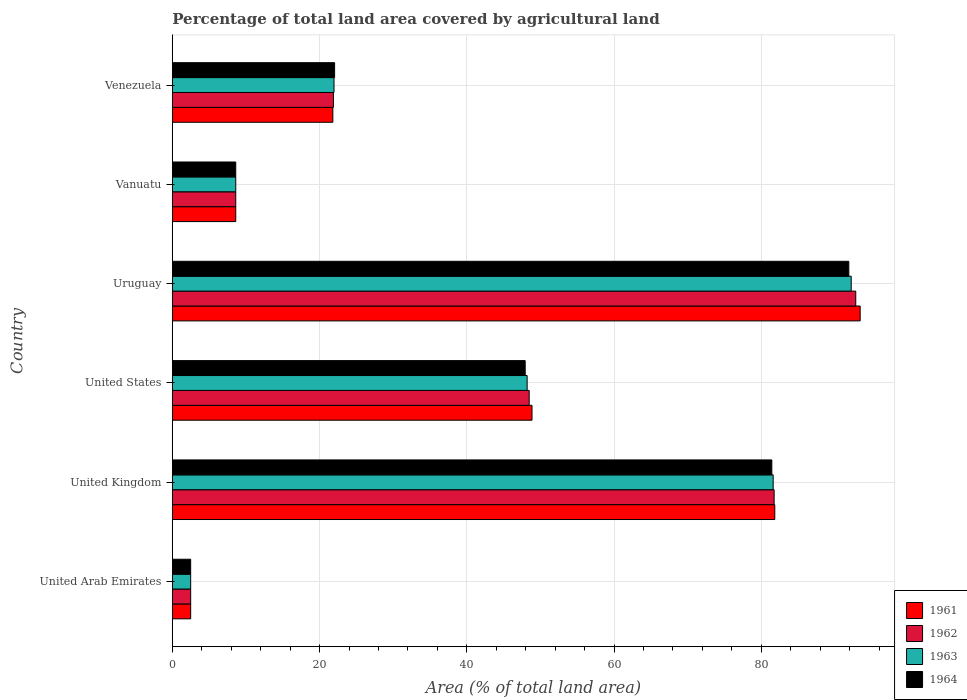How many different coloured bars are there?
Offer a very short reply. 4. How many groups of bars are there?
Keep it short and to the point. 6. How many bars are there on the 1st tick from the top?
Offer a very short reply. 4. How many bars are there on the 3rd tick from the bottom?
Your answer should be very brief. 4. What is the label of the 1st group of bars from the top?
Your response must be concise. Venezuela. What is the percentage of agricultural land in 1963 in Uruguay?
Offer a very short reply. 92.22. Across all countries, what is the maximum percentage of agricultural land in 1963?
Ensure brevity in your answer.  92.22. Across all countries, what is the minimum percentage of agricultural land in 1961?
Provide a short and direct response. 2.49. In which country was the percentage of agricultural land in 1962 maximum?
Offer a very short reply. Uruguay. In which country was the percentage of agricultural land in 1961 minimum?
Provide a succinct answer. United Arab Emirates. What is the total percentage of agricultural land in 1964 in the graph?
Ensure brevity in your answer.  254.42. What is the difference between the percentage of agricultural land in 1962 in Vanuatu and that in Venezuela?
Offer a terse response. -13.27. What is the difference between the percentage of agricultural land in 1961 in Uruguay and the percentage of agricultural land in 1962 in United Arab Emirates?
Your answer should be compact. 90.95. What is the average percentage of agricultural land in 1964 per country?
Offer a very short reply. 42.4. What is the difference between the percentage of agricultural land in 1962 and percentage of agricultural land in 1963 in Venezuela?
Keep it short and to the point. -0.08. What is the ratio of the percentage of agricultural land in 1962 in United Arab Emirates to that in United Kingdom?
Ensure brevity in your answer.  0.03. Is the difference between the percentage of agricultural land in 1962 in United States and Vanuatu greater than the difference between the percentage of agricultural land in 1963 in United States and Vanuatu?
Your answer should be compact. Yes. What is the difference between the highest and the second highest percentage of agricultural land in 1964?
Offer a very short reply. 10.46. What is the difference between the highest and the lowest percentage of agricultural land in 1961?
Provide a short and direct response. 90.95. What does the 4th bar from the bottom in Vanuatu represents?
Offer a terse response. 1964. Are all the bars in the graph horizontal?
Keep it short and to the point. Yes. How many countries are there in the graph?
Offer a very short reply. 6. Are the values on the major ticks of X-axis written in scientific E-notation?
Offer a terse response. No. Does the graph contain any zero values?
Offer a terse response. No. Where does the legend appear in the graph?
Ensure brevity in your answer.  Bottom right. How many legend labels are there?
Keep it short and to the point. 4. What is the title of the graph?
Provide a succinct answer. Percentage of total land area covered by agricultural land. What is the label or title of the X-axis?
Keep it short and to the point. Area (% of total land area). What is the Area (% of total land area) in 1961 in United Arab Emirates?
Give a very brief answer. 2.49. What is the Area (% of total land area) of 1962 in United Arab Emirates?
Keep it short and to the point. 2.49. What is the Area (% of total land area) in 1963 in United Arab Emirates?
Provide a succinct answer. 2.49. What is the Area (% of total land area) in 1964 in United Arab Emirates?
Give a very brief answer. 2.49. What is the Area (% of total land area) in 1961 in United Kingdom?
Your response must be concise. 81.84. What is the Area (% of total land area) of 1962 in United Kingdom?
Make the answer very short. 81.76. What is the Area (% of total land area) of 1963 in United Kingdom?
Your response must be concise. 81.62. What is the Area (% of total land area) in 1964 in United Kingdom?
Keep it short and to the point. 81.44. What is the Area (% of total land area) in 1961 in United States?
Your answer should be very brief. 48.86. What is the Area (% of total land area) of 1962 in United States?
Provide a short and direct response. 48.48. What is the Area (% of total land area) of 1963 in United States?
Keep it short and to the point. 48.2. What is the Area (% of total land area) in 1964 in United States?
Offer a terse response. 47.93. What is the Area (% of total land area) in 1961 in Uruguay?
Provide a short and direct response. 93.44. What is the Area (% of total land area) of 1962 in Uruguay?
Offer a very short reply. 92.84. What is the Area (% of total land area) of 1963 in Uruguay?
Your answer should be compact. 92.22. What is the Area (% of total land area) of 1964 in Uruguay?
Your answer should be compact. 91.9. What is the Area (% of total land area) in 1961 in Vanuatu?
Ensure brevity in your answer.  8.61. What is the Area (% of total land area) in 1962 in Vanuatu?
Your response must be concise. 8.61. What is the Area (% of total land area) in 1963 in Vanuatu?
Give a very brief answer. 8.61. What is the Area (% of total land area) in 1964 in Vanuatu?
Provide a short and direct response. 8.61. What is the Area (% of total land area) in 1961 in Venezuela?
Your answer should be very brief. 21.8. What is the Area (% of total land area) of 1962 in Venezuela?
Your response must be concise. 21.88. What is the Area (% of total land area) of 1963 in Venezuela?
Offer a terse response. 21.96. What is the Area (% of total land area) in 1964 in Venezuela?
Your response must be concise. 22.04. Across all countries, what is the maximum Area (% of total land area) in 1961?
Offer a terse response. 93.44. Across all countries, what is the maximum Area (% of total land area) in 1962?
Keep it short and to the point. 92.84. Across all countries, what is the maximum Area (% of total land area) of 1963?
Offer a terse response. 92.22. Across all countries, what is the maximum Area (% of total land area) in 1964?
Give a very brief answer. 91.9. Across all countries, what is the minimum Area (% of total land area) of 1961?
Provide a short and direct response. 2.49. Across all countries, what is the minimum Area (% of total land area) in 1962?
Give a very brief answer. 2.49. Across all countries, what is the minimum Area (% of total land area) of 1963?
Your response must be concise. 2.49. Across all countries, what is the minimum Area (% of total land area) in 1964?
Offer a terse response. 2.49. What is the total Area (% of total land area) in 1961 in the graph?
Keep it short and to the point. 257.05. What is the total Area (% of total land area) in 1962 in the graph?
Keep it short and to the point. 256.06. What is the total Area (% of total land area) of 1963 in the graph?
Make the answer very short. 255.11. What is the total Area (% of total land area) in 1964 in the graph?
Give a very brief answer. 254.42. What is the difference between the Area (% of total land area) of 1961 in United Arab Emirates and that in United Kingdom?
Give a very brief answer. -79.35. What is the difference between the Area (% of total land area) in 1962 in United Arab Emirates and that in United Kingdom?
Offer a terse response. -79.27. What is the difference between the Area (% of total land area) of 1963 in United Arab Emirates and that in United Kingdom?
Offer a terse response. -79.13. What is the difference between the Area (% of total land area) in 1964 in United Arab Emirates and that in United Kingdom?
Keep it short and to the point. -78.95. What is the difference between the Area (% of total land area) of 1961 in United Arab Emirates and that in United States?
Keep it short and to the point. -46.37. What is the difference between the Area (% of total land area) in 1962 in United Arab Emirates and that in United States?
Make the answer very short. -45.99. What is the difference between the Area (% of total land area) of 1963 in United Arab Emirates and that in United States?
Offer a very short reply. -45.71. What is the difference between the Area (% of total land area) in 1964 in United Arab Emirates and that in United States?
Offer a very short reply. -45.44. What is the difference between the Area (% of total land area) in 1961 in United Arab Emirates and that in Uruguay?
Ensure brevity in your answer.  -90.95. What is the difference between the Area (% of total land area) of 1962 in United Arab Emirates and that in Uruguay?
Your answer should be compact. -90.35. What is the difference between the Area (% of total land area) in 1963 in United Arab Emirates and that in Uruguay?
Provide a short and direct response. -89.74. What is the difference between the Area (% of total land area) of 1964 in United Arab Emirates and that in Uruguay?
Offer a terse response. -89.41. What is the difference between the Area (% of total land area) in 1961 in United Arab Emirates and that in Vanuatu?
Provide a succinct answer. -6.13. What is the difference between the Area (% of total land area) in 1962 in United Arab Emirates and that in Vanuatu?
Offer a terse response. -6.13. What is the difference between the Area (% of total land area) of 1963 in United Arab Emirates and that in Vanuatu?
Your answer should be very brief. -6.13. What is the difference between the Area (% of total land area) in 1964 in United Arab Emirates and that in Vanuatu?
Provide a succinct answer. -6.13. What is the difference between the Area (% of total land area) in 1961 in United Arab Emirates and that in Venezuela?
Your answer should be compact. -19.32. What is the difference between the Area (% of total land area) of 1962 in United Arab Emirates and that in Venezuela?
Provide a succinct answer. -19.4. What is the difference between the Area (% of total land area) in 1963 in United Arab Emirates and that in Venezuela?
Provide a short and direct response. -19.47. What is the difference between the Area (% of total land area) of 1964 in United Arab Emirates and that in Venezuela?
Your response must be concise. -19.56. What is the difference between the Area (% of total land area) in 1961 in United Kingdom and that in United States?
Your answer should be compact. 32.98. What is the difference between the Area (% of total land area) in 1962 in United Kingdom and that in United States?
Offer a very short reply. 33.28. What is the difference between the Area (% of total land area) in 1963 in United Kingdom and that in United States?
Provide a succinct answer. 33.42. What is the difference between the Area (% of total land area) of 1964 in United Kingdom and that in United States?
Provide a short and direct response. 33.51. What is the difference between the Area (% of total land area) in 1961 in United Kingdom and that in Uruguay?
Provide a succinct answer. -11.6. What is the difference between the Area (% of total land area) in 1962 in United Kingdom and that in Uruguay?
Provide a short and direct response. -11.09. What is the difference between the Area (% of total land area) in 1963 in United Kingdom and that in Uruguay?
Your answer should be very brief. -10.6. What is the difference between the Area (% of total land area) of 1964 in United Kingdom and that in Uruguay?
Your response must be concise. -10.46. What is the difference between the Area (% of total land area) in 1961 in United Kingdom and that in Vanuatu?
Ensure brevity in your answer.  73.23. What is the difference between the Area (% of total land area) in 1962 in United Kingdom and that in Vanuatu?
Provide a succinct answer. 73.14. What is the difference between the Area (% of total land area) in 1963 in United Kingdom and that in Vanuatu?
Provide a short and direct response. 73.01. What is the difference between the Area (% of total land area) of 1964 in United Kingdom and that in Vanuatu?
Your answer should be compact. 72.83. What is the difference between the Area (% of total land area) of 1961 in United Kingdom and that in Venezuela?
Your answer should be compact. 60.04. What is the difference between the Area (% of total land area) of 1962 in United Kingdom and that in Venezuela?
Offer a very short reply. 59.87. What is the difference between the Area (% of total land area) in 1963 in United Kingdom and that in Venezuela?
Offer a terse response. 59.66. What is the difference between the Area (% of total land area) in 1964 in United Kingdom and that in Venezuela?
Offer a terse response. 59.4. What is the difference between the Area (% of total land area) of 1961 in United States and that in Uruguay?
Your answer should be compact. -44.58. What is the difference between the Area (% of total land area) in 1962 in United States and that in Uruguay?
Offer a very short reply. -44.36. What is the difference between the Area (% of total land area) of 1963 in United States and that in Uruguay?
Offer a terse response. -44.03. What is the difference between the Area (% of total land area) in 1964 in United States and that in Uruguay?
Your response must be concise. -43.97. What is the difference between the Area (% of total land area) of 1961 in United States and that in Vanuatu?
Keep it short and to the point. 40.25. What is the difference between the Area (% of total land area) of 1962 in United States and that in Vanuatu?
Your response must be concise. 39.86. What is the difference between the Area (% of total land area) of 1963 in United States and that in Vanuatu?
Your answer should be very brief. 39.58. What is the difference between the Area (% of total land area) in 1964 in United States and that in Vanuatu?
Keep it short and to the point. 39.32. What is the difference between the Area (% of total land area) of 1961 in United States and that in Venezuela?
Make the answer very short. 27.06. What is the difference between the Area (% of total land area) of 1962 in United States and that in Venezuela?
Provide a succinct answer. 26.59. What is the difference between the Area (% of total land area) in 1963 in United States and that in Venezuela?
Ensure brevity in your answer.  26.24. What is the difference between the Area (% of total land area) of 1964 in United States and that in Venezuela?
Your response must be concise. 25.89. What is the difference between the Area (% of total land area) in 1961 in Uruguay and that in Vanuatu?
Provide a succinct answer. 84.83. What is the difference between the Area (% of total land area) in 1962 in Uruguay and that in Vanuatu?
Your answer should be compact. 84.23. What is the difference between the Area (% of total land area) of 1963 in Uruguay and that in Vanuatu?
Your answer should be compact. 83.61. What is the difference between the Area (% of total land area) in 1964 in Uruguay and that in Vanuatu?
Offer a very short reply. 83.28. What is the difference between the Area (% of total land area) in 1961 in Uruguay and that in Venezuela?
Provide a succinct answer. 71.64. What is the difference between the Area (% of total land area) of 1962 in Uruguay and that in Venezuela?
Provide a short and direct response. 70.96. What is the difference between the Area (% of total land area) of 1963 in Uruguay and that in Venezuela?
Ensure brevity in your answer.  70.26. What is the difference between the Area (% of total land area) of 1964 in Uruguay and that in Venezuela?
Provide a short and direct response. 69.85. What is the difference between the Area (% of total land area) in 1961 in Vanuatu and that in Venezuela?
Keep it short and to the point. -13.19. What is the difference between the Area (% of total land area) in 1962 in Vanuatu and that in Venezuela?
Provide a succinct answer. -13.27. What is the difference between the Area (% of total land area) in 1963 in Vanuatu and that in Venezuela?
Provide a short and direct response. -13.35. What is the difference between the Area (% of total land area) in 1964 in Vanuatu and that in Venezuela?
Ensure brevity in your answer.  -13.43. What is the difference between the Area (% of total land area) of 1961 in United Arab Emirates and the Area (% of total land area) of 1962 in United Kingdom?
Ensure brevity in your answer.  -79.27. What is the difference between the Area (% of total land area) of 1961 in United Arab Emirates and the Area (% of total land area) of 1963 in United Kingdom?
Keep it short and to the point. -79.13. What is the difference between the Area (% of total land area) of 1961 in United Arab Emirates and the Area (% of total land area) of 1964 in United Kingdom?
Make the answer very short. -78.95. What is the difference between the Area (% of total land area) in 1962 in United Arab Emirates and the Area (% of total land area) in 1963 in United Kingdom?
Provide a succinct answer. -79.13. What is the difference between the Area (% of total land area) in 1962 in United Arab Emirates and the Area (% of total land area) in 1964 in United Kingdom?
Make the answer very short. -78.95. What is the difference between the Area (% of total land area) of 1963 in United Arab Emirates and the Area (% of total land area) of 1964 in United Kingdom?
Provide a succinct answer. -78.95. What is the difference between the Area (% of total land area) in 1961 in United Arab Emirates and the Area (% of total land area) in 1962 in United States?
Offer a terse response. -45.99. What is the difference between the Area (% of total land area) in 1961 in United Arab Emirates and the Area (% of total land area) in 1963 in United States?
Your response must be concise. -45.71. What is the difference between the Area (% of total land area) of 1961 in United Arab Emirates and the Area (% of total land area) of 1964 in United States?
Keep it short and to the point. -45.44. What is the difference between the Area (% of total land area) in 1962 in United Arab Emirates and the Area (% of total land area) in 1963 in United States?
Give a very brief answer. -45.71. What is the difference between the Area (% of total land area) of 1962 in United Arab Emirates and the Area (% of total land area) of 1964 in United States?
Give a very brief answer. -45.44. What is the difference between the Area (% of total land area) in 1963 in United Arab Emirates and the Area (% of total land area) in 1964 in United States?
Your response must be concise. -45.44. What is the difference between the Area (% of total land area) of 1961 in United Arab Emirates and the Area (% of total land area) of 1962 in Uruguay?
Your answer should be compact. -90.35. What is the difference between the Area (% of total land area) of 1961 in United Arab Emirates and the Area (% of total land area) of 1963 in Uruguay?
Your answer should be compact. -89.74. What is the difference between the Area (% of total land area) of 1961 in United Arab Emirates and the Area (% of total land area) of 1964 in Uruguay?
Provide a short and direct response. -89.41. What is the difference between the Area (% of total land area) in 1962 in United Arab Emirates and the Area (% of total land area) in 1963 in Uruguay?
Keep it short and to the point. -89.74. What is the difference between the Area (% of total land area) in 1962 in United Arab Emirates and the Area (% of total land area) in 1964 in Uruguay?
Your response must be concise. -89.41. What is the difference between the Area (% of total land area) of 1963 in United Arab Emirates and the Area (% of total land area) of 1964 in Uruguay?
Offer a terse response. -89.41. What is the difference between the Area (% of total land area) of 1961 in United Arab Emirates and the Area (% of total land area) of 1962 in Vanuatu?
Give a very brief answer. -6.13. What is the difference between the Area (% of total land area) in 1961 in United Arab Emirates and the Area (% of total land area) in 1963 in Vanuatu?
Your response must be concise. -6.13. What is the difference between the Area (% of total land area) in 1961 in United Arab Emirates and the Area (% of total land area) in 1964 in Vanuatu?
Provide a short and direct response. -6.13. What is the difference between the Area (% of total land area) in 1962 in United Arab Emirates and the Area (% of total land area) in 1963 in Vanuatu?
Provide a succinct answer. -6.13. What is the difference between the Area (% of total land area) in 1962 in United Arab Emirates and the Area (% of total land area) in 1964 in Vanuatu?
Your answer should be very brief. -6.13. What is the difference between the Area (% of total land area) of 1963 in United Arab Emirates and the Area (% of total land area) of 1964 in Vanuatu?
Your response must be concise. -6.13. What is the difference between the Area (% of total land area) of 1961 in United Arab Emirates and the Area (% of total land area) of 1962 in Venezuela?
Your answer should be very brief. -19.4. What is the difference between the Area (% of total land area) in 1961 in United Arab Emirates and the Area (% of total land area) in 1963 in Venezuela?
Make the answer very short. -19.47. What is the difference between the Area (% of total land area) in 1961 in United Arab Emirates and the Area (% of total land area) in 1964 in Venezuela?
Give a very brief answer. -19.56. What is the difference between the Area (% of total land area) of 1962 in United Arab Emirates and the Area (% of total land area) of 1963 in Venezuela?
Ensure brevity in your answer.  -19.47. What is the difference between the Area (% of total land area) of 1962 in United Arab Emirates and the Area (% of total land area) of 1964 in Venezuela?
Your answer should be compact. -19.56. What is the difference between the Area (% of total land area) in 1963 in United Arab Emirates and the Area (% of total land area) in 1964 in Venezuela?
Ensure brevity in your answer.  -19.56. What is the difference between the Area (% of total land area) in 1961 in United Kingdom and the Area (% of total land area) in 1962 in United States?
Ensure brevity in your answer.  33.37. What is the difference between the Area (% of total land area) of 1961 in United Kingdom and the Area (% of total land area) of 1963 in United States?
Keep it short and to the point. 33.64. What is the difference between the Area (% of total land area) in 1961 in United Kingdom and the Area (% of total land area) in 1964 in United States?
Your answer should be very brief. 33.91. What is the difference between the Area (% of total land area) of 1962 in United Kingdom and the Area (% of total land area) of 1963 in United States?
Keep it short and to the point. 33.56. What is the difference between the Area (% of total land area) in 1962 in United Kingdom and the Area (% of total land area) in 1964 in United States?
Provide a succinct answer. 33.82. What is the difference between the Area (% of total land area) of 1963 in United Kingdom and the Area (% of total land area) of 1964 in United States?
Provide a short and direct response. 33.69. What is the difference between the Area (% of total land area) of 1961 in United Kingdom and the Area (% of total land area) of 1962 in Uruguay?
Your answer should be very brief. -11. What is the difference between the Area (% of total land area) of 1961 in United Kingdom and the Area (% of total land area) of 1963 in Uruguay?
Give a very brief answer. -10.38. What is the difference between the Area (% of total land area) of 1961 in United Kingdom and the Area (% of total land area) of 1964 in Uruguay?
Offer a terse response. -10.06. What is the difference between the Area (% of total land area) of 1962 in United Kingdom and the Area (% of total land area) of 1963 in Uruguay?
Give a very brief answer. -10.47. What is the difference between the Area (% of total land area) in 1962 in United Kingdom and the Area (% of total land area) in 1964 in Uruguay?
Your answer should be compact. -10.14. What is the difference between the Area (% of total land area) of 1963 in United Kingdom and the Area (% of total land area) of 1964 in Uruguay?
Your response must be concise. -10.28. What is the difference between the Area (% of total land area) in 1961 in United Kingdom and the Area (% of total land area) in 1962 in Vanuatu?
Make the answer very short. 73.23. What is the difference between the Area (% of total land area) of 1961 in United Kingdom and the Area (% of total land area) of 1963 in Vanuatu?
Your answer should be very brief. 73.23. What is the difference between the Area (% of total land area) of 1961 in United Kingdom and the Area (% of total land area) of 1964 in Vanuatu?
Your response must be concise. 73.23. What is the difference between the Area (% of total land area) in 1962 in United Kingdom and the Area (% of total land area) in 1963 in Vanuatu?
Your answer should be very brief. 73.14. What is the difference between the Area (% of total land area) of 1962 in United Kingdom and the Area (% of total land area) of 1964 in Vanuatu?
Provide a short and direct response. 73.14. What is the difference between the Area (% of total land area) of 1963 in United Kingdom and the Area (% of total land area) of 1964 in Vanuatu?
Keep it short and to the point. 73.01. What is the difference between the Area (% of total land area) in 1961 in United Kingdom and the Area (% of total land area) in 1962 in Venezuela?
Offer a very short reply. 59.96. What is the difference between the Area (% of total land area) in 1961 in United Kingdom and the Area (% of total land area) in 1963 in Venezuela?
Offer a terse response. 59.88. What is the difference between the Area (% of total land area) of 1961 in United Kingdom and the Area (% of total land area) of 1964 in Venezuela?
Your answer should be very brief. 59.8. What is the difference between the Area (% of total land area) in 1962 in United Kingdom and the Area (% of total land area) in 1963 in Venezuela?
Ensure brevity in your answer.  59.79. What is the difference between the Area (% of total land area) in 1962 in United Kingdom and the Area (% of total land area) in 1964 in Venezuela?
Provide a short and direct response. 59.71. What is the difference between the Area (% of total land area) of 1963 in United Kingdom and the Area (% of total land area) of 1964 in Venezuela?
Provide a short and direct response. 59.58. What is the difference between the Area (% of total land area) of 1961 in United States and the Area (% of total land area) of 1962 in Uruguay?
Make the answer very short. -43.98. What is the difference between the Area (% of total land area) in 1961 in United States and the Area (% of total land area) in 1963 in Uruguay?
Give a very brief answer. -43.36. What is the difference between the Area (% of total land area) in 1961 in United States and the Area (% of total land area) in 1964 in Uruguay?
Your answer should be very brief. -43.04. What is the difference between the Area (% of total land area) of 1962 in United States and the Area (% of total land area) of 1963 in Uruguay?
Give a very brief answer. -43.75. What is the difference between the Area (% of total land area) of 1962 in United States and the Area (% of total land area) of 1964 in Uruguay?
Offer a terse response. -43.42. What is the difference between the Area (% of total land area) of 1963 in United States and the Area (% of total land area) of 1964 in Uruguay?
Your response must be concise. -43.7. What is the difference between the Area (% of total land area) of 1961 in United States and the Area (% of total land area) of 1962 in Vanuatu?
Ensure brevity in your answer.  40.25. What is the difference between the Area (% of total land area) in 1961 in United States and the Area (% of total land area) in 1963 in Vanuatu?
Provide a succinct answer. 40.25. What is the difference between the Area (% of total land area) of 1961 in United States and the Area (% of total land area) of 1964 in Vanuatu?
Your answer should be compact. 40.25. What is the difference between the Area (% of total land area) in 1962 in United States and the Area (% of total land area) in 1963 in Vanuatu?
Make the answer very short. 39.86. What is the difference between the Area (% of total land area) of 1962 in United States and the Area (% of total land area) of 1964 in Vanuatu?
Give a very brief answer. 39.86. What is the difference between the Area (% of total land area) of 1963 in United States and the Area (% of total land area) of 1964 in Vanuatu?
Your answer should be very brief. 39.58. What is the difference between the Area (% of total land area) in 1961 in United States and the Area (% of total land area) in 1962 in Venezuela?
Your answer should be compact. 26.98. What is the difference between the Area (% of total land area) of 1961 in United States and the Area (% of total land area) of 1963 in Venezuela?
Your answer should be compact. 26.9. What is the difference between the Area (% of total land area) of 1961 in United States and the Area (% of total land area) of 1964 in Venezuela?
Provide a succinct answer. 26.82. What is the difference between the Area (% of total land area) in 1962 in United States and the Area (% of total land area) in 1963 in Venezuela?
Your answer should be very brief. 26.51. What is the difference between the Area (% of total land area) in 1962 in United States and the Area (% of total land area) in 1964 in Venezuela?
Ensure brevity in your answer.  26.43. What is the difference between the Area (% of total land area) of 1963 in United States and the Area (% of total land area) of 1964 in Venezuela?
Provide a succinct answer. 26.15. What is the difference between the Area (% of total land area) of 1961 in Uruguay and the Area (% of total land area) of 1962 in Vanuatu?
Your answer should be very brief. 84.83. What is the difference between the Area (% of total land area) in 1961 in Uruguay and the Area (% of total land area) in 1963 in Vanuatu?
Provide a succinct answer. 84.83. What is the difference between the Area (% of total land area) of 1961 in Uruguay and the Area (% of total land area) of 1964 in Vanuatu?
Make the answer very short. 84.83. What is the difference between the Area (% of total land area) of 1962 in Uruguay and the Area (% of total land area) of 1963 in Vanuatu?
Give a very brief answer. 84.23. What is the difference between the Area (% of total land area) of 1962 in Uruguay and the Area (% of total land area) of 1964 in Vanuatu?
Offer a terse response. 84.23. What is the difference between the Area (% of total land area) of 1963 in Uruguay and the Area (% of total land area) of 1964 in Vanuatu?
Offer a terse response. 83.61. What is the difference between the Area (% of total land area) in 1961 in Uruguay and the Area (% of total land area) in 1962 in Venezuela?
Keep it short and to the point. 71.56. What is the difference between the Area (% of total land area) of 1961 in Uruguay and the Area (% of total land area) of 1963 in Venezuela?
Your response must be concise. 71.48. What is the difference between the Area (% of total land area) of 1961 in Uruguay and the Area (% of total land area) of 1964 in Venezuela?
Provide a short and direct response. 71.4. What is the difference between the Area (% of total land area) in 1962 in Uruguay and the Area (% of total land area) in 1963 in Venezuela?
Offer a terse response. 70.88. What is the difference between the Area (% of total land area) in 1962 in Uruguay and the Area (% of total land area) in 1964 in Venezuela?
Give a very brief answer. 70.8. What is the difference between the Area (% of total land area) in 1963 in Uruguay and the Area (% of total land area) in 1964 in Venezuela?
Make the answer very short. 70.18. What is the difference between the Area (% of total land area) in 1961 in Vanuatu and the Area (% of total land area) in 1962 in Venezuela?
Give a very brief answer. -13.27. What is the difference between the Area (% of total land area) of 1961 in Vanuatu and the Area (% of total land area) of 1963 in Venezuela?
Provide a short and direct response. -13.35. What is the difference between the Area (% of total land area) of 1961 in Vanuatu and the Area (% of total land area) of 1964 in Venezuela?
Ensure brevity in your answer.  -13.43. What is the difference between the Area (% of total land area) of 1962 in Vanuatu and the Area (% of total land area) of 1963 in Venezuela?
Provide a succinct answer. -13.35. What is the difference between the Area (% of total land area) in 1962 in Vanuatu and the Area (% of total land area) in 1964 in Venezuela?
Provide a succinct answer. -13.43. What is the difference between the Area (% of total land area) of 1963 in Vanuatu and the Area (% of total land area) of 1964 in Venezuela?
Offer a very short reply. -13.43. What is the average Area (% of total land area) of 1961 per country?
Provide a short and direct response. 42.84. What is the average Area (% of total land area) in 1962 per country?
Offer a terse response. 42.68. What is the average Area (% of total land area) in 1963 per country?
Offer a terse response. 42.52. What is the average Area (% of total land area) of 1964 per country?
Provide a succinct answer. 42.4. What is the difference between the Area (% of total land area) of 1961 and Area (% of total land area) of 1962 in United Arab Emirates?
Offer a very short reply. 0. What is the difference between the Area (% of total land area) of 1962 and Area (% of total land area) of 1963 in United Arab Emirates?
Offer a terse response. 0. What is the difference between the Area (% of total land area) in 1962 and Area (% of total land area) in 1964 in United Arab Emirates?
Keep it short and to the point. 0. What is the difference between the Area (% of total land area) of 1961 and Area (% of total land area) of 1962 in United Kingdom?
Offer a very short reply. 0.09. What is the difference between the Area (% of total land area) of 1961 and Area (% of total land area) of 1963 in United Kingdom?
Offer a terse response. 0.22. What is the difference between the Area (% of total land area) in 1961 and Area (% of total land area) in 1964 in United Kingdom?
Make the answer very short. 0.4. What is the difference between the Area (% of total land area) in 1962 and Area (% of total land area) in 1963 in United Kingdom?
Offer a terse response. 0.13. What is the difference between the Area (% of total land area) of 1962 and Area (% of total land area) of 1964 in United Kingdom?
Your answer should be very brief. 0.31. What is the difference between the Area (% of total land area) in 1963 and Area (% of total land area) in 1964 in United Kingdom?
Offer a terse response. 0.18. What is the difference between the Area (% of total land area) in 1961 and Area (% of total land area) in 1962 in United States?
Offer a very short reply. 0.38. What is the difference between the Area (% of total land area) in 1961 and Area (% of total land area) in 1963 in United States?
Offer a very short reply. 0.66. What is the difference between the Area (% of total land area) in 1961 and Area (% of total land area) in 1964 in United States?
Ensure brevity in your answer.  0.93. What is the difference between the Area (% of total land area) in 1962 and Area (% of total land area) in 1963 in United States?
Provide a succinct answer. 0.28. What is the difference between the Area (% of total land area) of 1962 and Area (% of total land area) of 1964 in United States?
Make the answer very short. 0.54. What is the difference between the Area (% of total land area) in 1963 and Area (% of total land area) in 1964 in United States?
Give a very brief answer. 0.27. What is the difference between the Area (% of total land area) of 1961 and Area (% of total land area) of 1962 in Uruguay?
Give a very brief answer. 0.6. What is the difference between the Area (% of total land area) in 1961 and Area (% of total land area) in 1963 in Uruguay?
Offer a terse response. 1.22. What is the difference between the Area (% of total land area) in 1961 and Area (% of total land area) in 1964 in Uruguay?
Offer a very short reply. 1.54. What is the difference between the Area (% of total land area) of 1962 and Area (% of total land area) of 1963 in Uruguay?
Provide a short and direct response. 0.62. What is the difference between the Area (% of total land area) of 1962 and Area (% of total land area) of 1964 in Uruguay?
Offer a very short reply. 0.94. What is the difference between the Area (% of total land area) of 1963 and Area (% of total land area) of 1964 in Uruguay?
Your response must be concise. 0.33. What is the difference between the Area (% of total land area) of 1961 and Area (% of total land area) of 1962 in Vanuatu?
Provide a succinct answer. 0. What is the difference between the Area (% of total land area) of 1961 and Area (% of total land area) of 1963 in Vanuatu?
Provide a succinct answer. 0. What is the difference between the Area (% of total land area) of 1961 and Area (% of total land area) of 1964 in Vanuatu?
Give a very brief answer. 0. What is the difference between the Area (% of total land area) of 1963 and Area (% of total land area) of 1964 in Vanuatu?
Offer a very short reply. 0. What is the difference between the Area (% of total land area) in 1961 and Area (% of total land area) in 1962 in Venezuela?
Your answer should be compact. -0.08. What is the difference between the Area (% of total land area) in 1961 and Area (% of total land area) in 1963 in Venezuela?
Make the answer very short. -0.16. What is the difference between the Area (% of total land area) in 1961 and Area (% of total land area) in 1964 in Venezuela?
Your response must be concise. -0.24. What is the difference between the Area (% of total land area) of 1962 and Area (% of total land area) of 1963 in Venezuela?
Your answer should be compact. -0.08. What is the difference between the Area (% of total land area) of 1962 and Area (% of total land area) of 1964 in Venezuela?
Provide a succinct answer. -0.16. What is the difference between the Area (% of total land area) in 1963 and Area (% of total land area) in 1964 in Venezuela?
Ensure brevity in your answer.  -0.08. What is the ratio of the Area (% of total land area) in 1961 in United Arab Emirates to that in United Kingdom?
Provide a succinct answer. 0.03. What is the ratio of the Area (% of total land area) in 1962 in United Arab Emirates to that in United Kingdom?
Offer a terse response. 0.03. What is the ratio of the Area (% of total land area) in 1963 in United Arab Emirates to that in United Kingdom?
Give a very brief answer. 0.03. What is the ratio of the Area (% of total land area) of 1964 in United Arab Emirates to that in United Kingdom?
Give a very brief answer. 0.03. What is the ratio of the Area (% of total land area) in 1961 in United Arab Emirates to that in United States?
Your answer should be very brief. 0.05. What is the ratio of the Area (% of total land area) of 1962 in United Arab Emirates to that in United States?
Make the answer very short. 0.05. What is the ratio of the Area (% of total land area) in 1963 in United Arab Emirates to that in United States?
Offer a terse response. 0.05. What is the ratio of the Area (% of total land area) of 1964 in United Arab Emirates to that in United States?
Make the answer very short. 0.05. What is the ratio of the Area (% of total land area) in 1961 in United Arab Emirates to that in Uruguay?
Offer a very short reply. 0.03. What is the ratio of the Area (% of total land area) of 1962 in United Arab Emirates to that in Uruguay?
Ensure brevity in your answer.  0.03. What is the ratio of the Area (% of total land area) of 1963 in United Arab Emirates to that in Uruguay?
Offer a very short reply. 0.03. What is the ratio of the Area (% of total land area) of 1964 in United Arab Emirates to that in Uruguay?
Ensure brevity in your answer.  0.03. What is the ratio of the Area (% of total land area) of 1961 in United Arab Emirates to that in Vanuatu?
Your answer should be very brief. 0.29. What is the ratio of the Area (% of total land area) of 1962 in United Arab Emirates to that in Vanuatu?
Your answer should be very brief. 0.29. What is the ratio of the Area (% of total land area) in 1963 in United Arab Emirates to that in Vanuatu?
Ensure brevity in your answer.  0.29. What is the ratio of the Area (% of total land area) of 1964 in United Arab Emirates to that in Vanuatu?
Offer a very short reply. 0.29. What is the ratio of the Area (% of total land area) of 1961 in United Arab Emirates to that in Venezuela?
Provide a short and direct response. 0.11. What is the ratio of the Area (% of total land area) in 1962 in United Arab Emirates to that in Venezuela?
Make the answer very short. 0.11. What is the ratio of the Area (% of total land area) in 1963 in United Arab Emirates to that in Venezuela?
Provide a succinct answer. 0.11. What is the ratio of the Area (% of total land area) of 1964 in United Arab Emirates to that in Venezuela?
Offer a terse response. 0.11. What is the ratio of the Area (% of total land area) of 1961 in United Kingdom to that in United States?
Make the answer very short. 1.68. What is the ratio of the Area (% of total land area) in 1962 in United Kingdom to that in United States?
Give a very brief answer. 1.69. What is the ratio of the Area (% of total land area) of 1963 in United Kingdom to that in United States?
Make the answer very short. 1.69. What is the ratio of the Area (% of total land area) in 1964 in United Kingdom to that in United States?
Give a very brief answer. 1.7. What is the ratio of the Area (% of total land area) of 1961 in United Kingdom to that in Uruguay?
Your answer should be very brief. 0.88. What is the ratio of the Area (% of total land area) in 1962 in United Kingdom to that in Uruguay?
Provide a succinct answer. 0.88. What is the ratio of the Area (% of total land area) in 1963 in United Kingdom to that in Uruguay?
Offer a terse response. 0.89. What is the ratio of the Area (% of total land area) in 1964 in United Kingdom to that in Uruguay?
Your response must be concise. 0.89. What is the ratio of the Area (% of total land area) in 1961 in United Kingdom to that in Vanuatu?
Your answer should be compact. 9.5. What is the ratio of the Area (% of total land area) in 1962 in United Kingdom to that in Vanuatu?
Ensure brevity in your answer.  9.49. What is the ratio of the Area (% of total land area) of 1963 in United Kingdom to that in Vanuatu?
Offer a terse response. 9.48. What is the ratio of the Area (% of total land area) in 1964 in United Kingdom to that in Vanuatu?
Keep it short and to the point. 9.45. What is the ratio of the Area (% of total land area) in 1961 in United Kingdom to that in Venezuela?
Offer a very short reply. 3.75. What is the ratio of the Area (% of total land area) in 1962 in United Kingdom to that in Venezuela?
Provide a succinct answer. 3.74. What is the ratio of the Area (% of total land area) of 1963 in United Kingdom to that in Venezuela?
Offer a terse response. 3.72. What is the ratio of the Area (% of total land area) of 1964 in United Kingdom to that in Venezuela?
Provide a short and direct response. 3.69. What is the ratio of the Area (% of total land area) of 1961 in United States to that in Uruguay?
Provide a short and direct response. 0.52. What is the ratio of the Area (% of total land area) in 1962 in United States to that in Uruguay?
Make the answer very short. 0.52. What is the ratio of the Area (% of total land area) of 1963 in United States to that in Uruguay?
Make the answer very short. 0.52. What is the ratio of the Area (% of total land area) of 1964 in United States to that in Uruguay?
Ensure brevity in your answer.  0.52. What is the ratio of the Area (% of total land area) in 1961 in United States to that in Vanuatu?
Offer a terse response. 5.67. What is the ratio of the Area (% of total land area) of 1962 in United States to that in Vanuatu?
Make the answer very short. 5.63. What is the ratio of the Area (% of total land area) of 1963 in United States to that in Vanuatu?
Give a very brief answer. 5.6. What is the ratio of the Area (% of total land area) in 1964 in United States to that in Vanuatu?
Offer a terse response. 5.56. What is the ratio of the Area (% of total land area) in 1961 in United States to that in Venezuela?
Give a very brief answer. 2.24. What is the ratio of the Area (% of total land area) of 1962 in United States to that in Venezuela?
Make the answer very short. 2.22. What is the ratio of the Area (% of total land area) in 1963 in United States to that in Venezuela?
Ensure brevity in your answer.  2.19. What is the ratio of the Area (% of total land area) in 1964 in United States to that in Venezuela?
Make the answer very short. 2.17. What is the ratio of the Area (% of total land area) of 1961 in Uruguay to that in Vanuatu?
Offer a terse response. 10.85. What is the ratio of the Area (% of total land area) of 1962 in Uruguay to that in Vanuatu?
Provide a succinct answer. 10.78. What is the ratio of the Area (% of total land area) of 1963 in Uruguay to that in Vanuatu?
Keep it short and to the point. 10.71. What is the ratio of the Area (% of total land area) in 1964 in Uruguay to that in Vanuatu?
Provide a short and direct response. 10.67. What is the ratio of the Area (% of total land area) of 1961 in Uruguay to that in Venezuela?
Provide a short and direct response. 4.29. What is the ratio of the Area (% of total land area) of 1962 in Uruguay to that in Venezuela?
Your answer should be compact. 4.24. What is the ratio of the Area (% of total land area) of 1963 in Uruguay to that in Venezuela?
Offer a very short reply. 4.2. What is the ratio of the Area (% of total land area) in 1964 in Uruguay to that in Venezuela?
Offer a terse response. 4.17. What is the ratio of the Area (% of total land area) in 1961 in Vanuatu to that in Venezuela?
Ensure brevity in your answer.  0.4. What is the ratio of the Area (% of total land area) of 1962 in Vanuatu to that in Venezuela?
Offer a terse response. 0.39. What is the ratio of the Area (% of total land area) in 1963 in Vanuatu to that in Venezuela?
Your answer should be compact. 0.39. What is the ratio of the Area (% of total land area) in 1964 in Vanuatu to that in Venezuela?
Ensure brevity in your answer.  0.39. What is the difference between the highest and the second highest Area (% of total land area) of 1961?
Your answer should be very brief. 11.6. What is the difference between the highest and the second highest Area (% of total land area) in 1962?
Give a very brief answer. 11.09. What is the difference between the highest and the second highest Area (% of total land area) of 1963?
Give a very brief answer. 10.6. What is the difference between the highest and the second highest Area (% of total land area) in 1964?
Provide a succinct answer. 10.46. What is the difference between the highest and the lowest Area (% of total land area) of 1961?
Your response must be concise. 90.95. What is the difference between the highest and the lowest Area (% of total land area) of 1962?
Make the answer very short. 90.35. What is the difference between the highest and the lowest Area (% of total land area) in 1963?
Ensure brevity in your answer.  89.74. What is the difference between the highest and the lowest Area (% of total land area) of 1964?
Your answer should be compact. 89.41. 